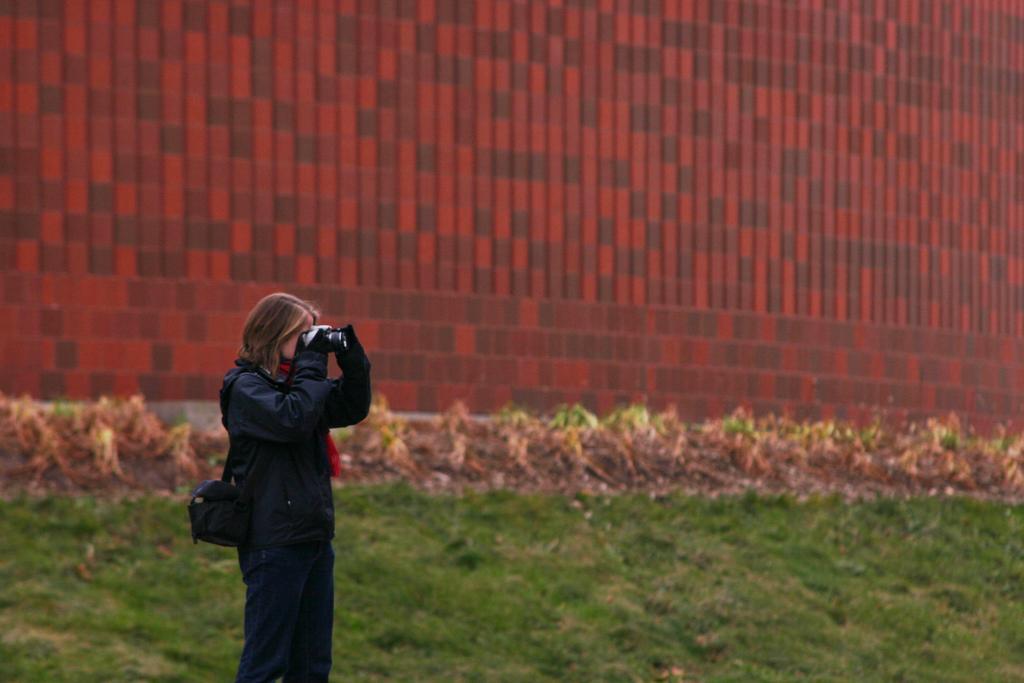In one or two sentences, can you explain what this image depicts? There is one woman standing on a grassy land and holding a camera at the bottom of this image. There is a wall in the background. 